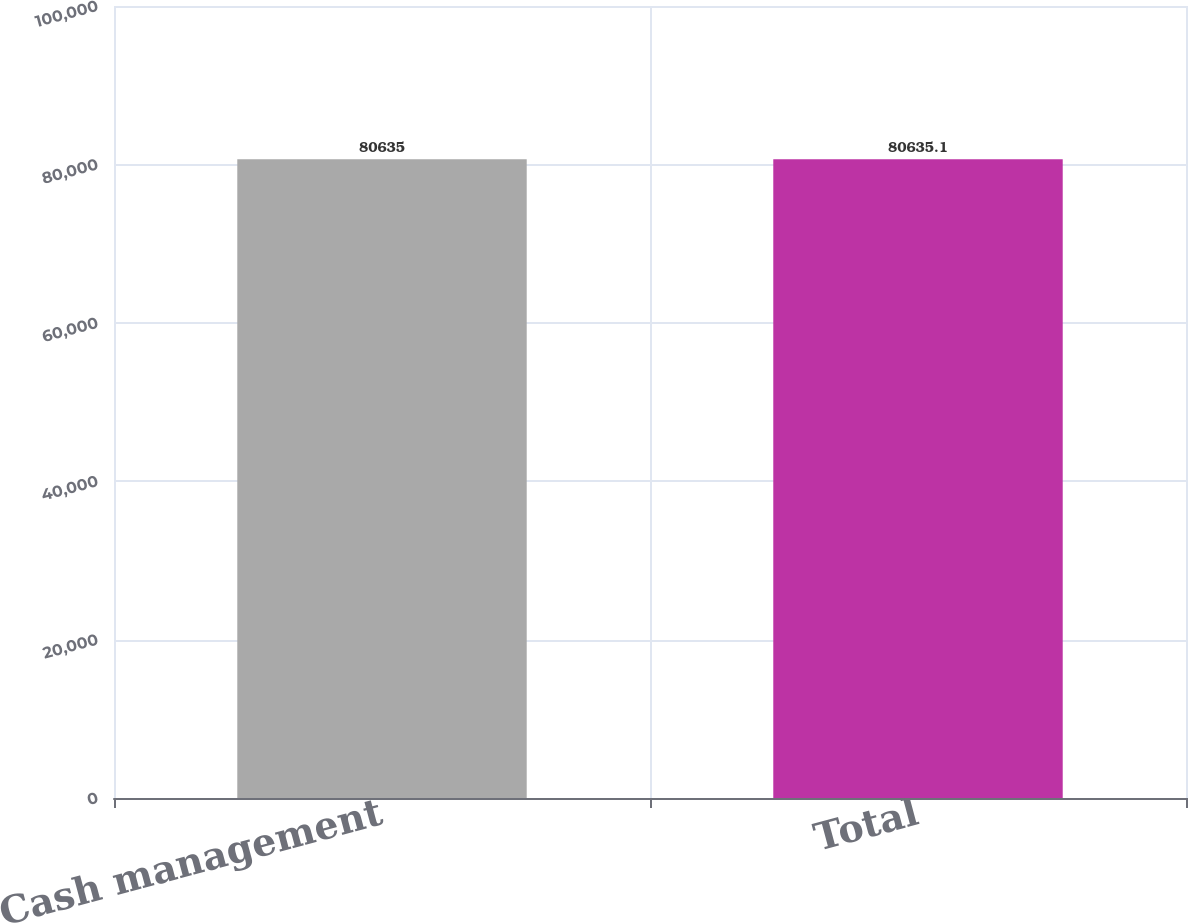Convert chart to OTSL. <chart><loc_0><loc_0><loc_500><loc_500><bar_chart><fcel>Cash management<fcel>Total<nl><fcel>80635<fcel>80635.1<nl></chart> 